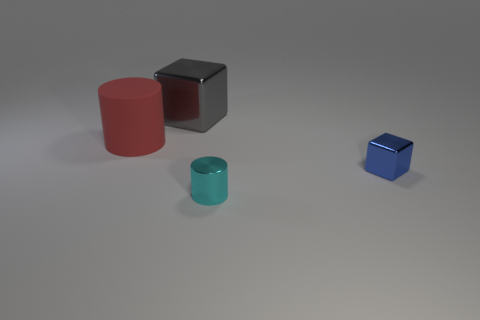There is a big thing in front of the big gray metallic block; does it have the same shape as the cyan metal object?
Offer a terse response. Yes. What is the material of the cylinder behind the tiny cyan metallic thing?
Your answer should be compact. Rubber. What shape is the matte object to the left of the tiny object that is on the left side of the small blue thing?
Your response must be concise. Cylinder. There is a tiny cyan metallic thing; is it the same shape as the tiny shiny thing behind the small cyan cylinder?
Ensure brevity in your answer.  No. How many gray metallic blocks are behind the metallic thing that is behind the rubber thing?
Ensure brevity in your answer.  0. What is the material of the big red thing that is the same shape as the cyan shiny thing?
Keep it short and to the point. Rubber. What number of cyan things are big metal blocks or cylinders?
Give a very brief answer. 1. Are there any other things of the same color as the metallic cylinder?
Your answer should be compact. No. There is a cube that is on the left side of the metallic object that is to the right of the small cyan thing; what color is it?
Offer a very short reply. Gray. Is the number of small metal cylinders that are behind the cyan metal object less than the number of cyan cylinders that are right of the big cylinder?
Give a very brief answer. Yes. 